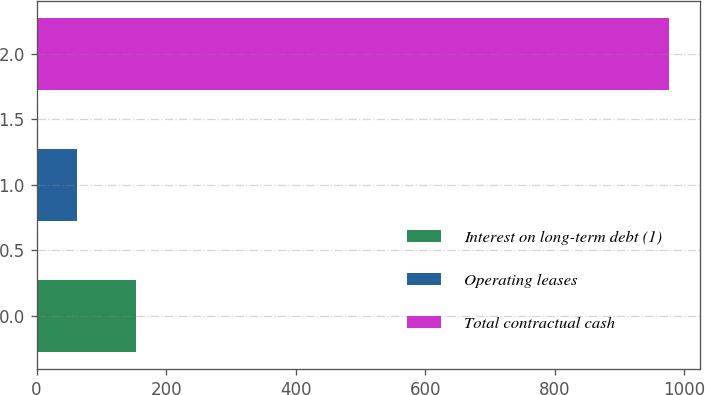Convert chart to OTSL. <chart><loc_0><loc_0><loc_500><loc_500><bar_chart><fcel>Interest on long-term debt (1)<fcel>Operating leases<fcel>Total contractual cash<nl><fcel>153.4<fcel>62<fcel>976<nl></chart> 